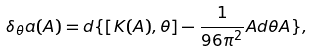Convert formula to latex. <formula><loc_0><loc_0><loc_500><loc_500>\delta _ { \theta } a ( A ) = d \{ [ K ( A ) , \theta ] - \frac { 1 } { 9 6 \pi ^ { 2 } } A d \theta A \} ,</formula> 